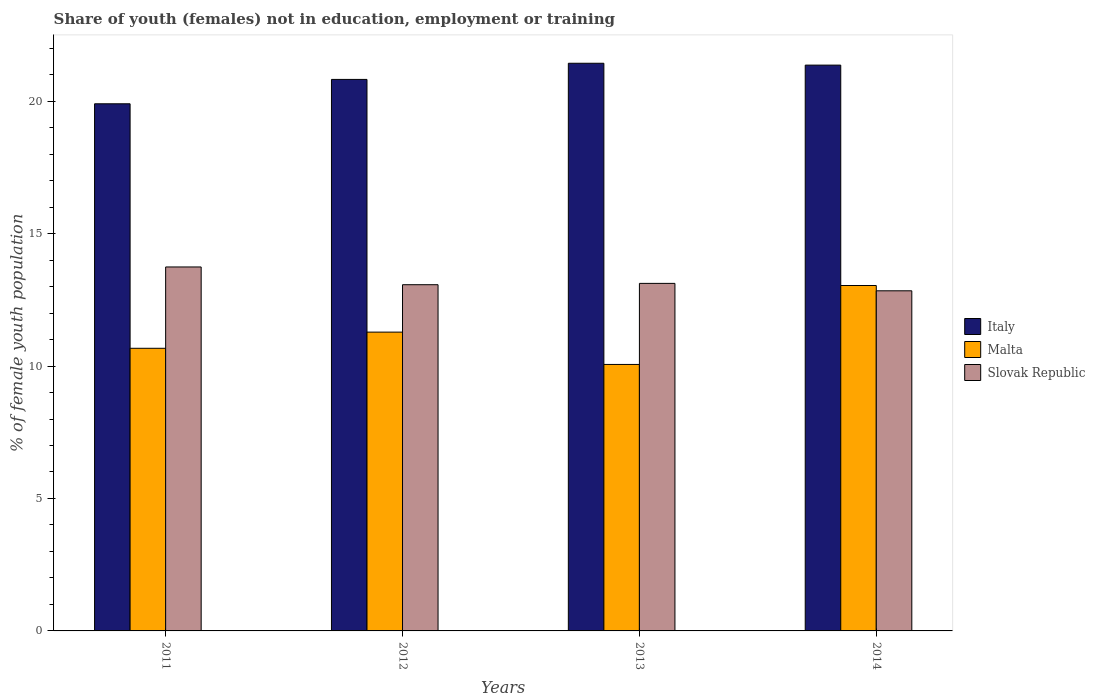How many bars are there on the 2nd tick from the left?
Your answer should be compact. 3. How many bars are there on the 3rd tick from the right?
Give a very brief answer. 3. What is the percentage of unemployed female population in in Malta in 2011?
Offer a very short reply. 10.67. Across all years, what is the maximum percentage of unemployed female population in in Malta?
Give a very brief answer. 13.04. Across all years, what is the minimum percentage of unemployed female population in in Italy?
Your response must be concise. 19.9. What is the total percentage of unemployed female population in in Italy in the graph?
Provide a short and direct response. 83.51. What is the difference between the percentage of unemployed female population in in Italy in 2012 and that in 2013?
Make the answer very short. -0.61. What is the difference between the percentage of unemployed female population in in Malta in 2011 and the percentage of unemployed female population in in Italy in 2012?
Offer a terse response. -10.15. What is the average percentage of unemployed female population in in Italy per year?
Your response must be concise. 20.88. In the year 2012, what is the difference between the percentage of unemployed female population in in Malta and percentage of unemployed female population in in Slovak Republic?
Your answer should be very brief. -1.79. In how many years, is the percentage of unemployed female population in in Slovak Republic greater than 14 %?
Your response must be concise. 0. What is the ratio of the percentage of unemployed female population in in Italy in 2013 to that in 2014?
Offer a terse response. 1. Is the difference between the percentage of unemployed female population in in Malta in 2012 and 2014 greater than the difference between the percentage of unemployed female population in in Slovak Republic in 2012 and 2014?
Ensure brevity in your answer.  No. What is the difference between the highest and the second highest percentage of unemployed female population in in Slovak Republic?
Keep it short and to the point. 0.62. What is the difference between the highest and the lowest percentage of unemployed female population in in Slovak Republic?
Your answer should be very brief. 0.9. In how many years, is the percentage of unemployed female population in in Italy greater than the average percentage of unemployed female population in in Italy taken over all years?
Your response must be concise. 2. Is the sum of the percentage of unemployed female population in in Italy in 2013 and 2014 greater than the maximum percentage of unemployed female population in in Slovak Republic across all years?
Make the answer very short. Yes. What does the 2nd bar from the left in 2014 represents?
Your response must be concise. Malta. What does the 2nd bar from the right in 2014 represents?
Ensure brevity in your answer.  Malta. How many bars are there?
Your response must be concise. 12. Are the values on the major ticks of Y-axis written in scientific E-notation?
Ensure brevity in your answer.  No. Does the graph contain any zero values?
Provide a short and direct response. No. Does the graph contain grids?
Give a very brief answer. No. Where does the legend appear in the graph?
Offer a very short reply. Center right. How many legend labels are there?
Keep it short and to the point. 3. How are the legend labels stacked?
Give a very brief answer. Vertical. What is the title of the graph?
Offer a very short reply. Share of youth (females) not in education, employment or training. What is the label or title of the Y-axis?
Your answer should be very brief. % of female youth population. What is the % of female youth population in Italy in 2011?
Your response must be concise. 19.9. What is the % of female youth population of Malta in 2011?
Give a very brief answer. 10.67. What is the % of female youth population of Slovak Republic in 2011?
Ensure brevity in your answer.  13.74. What is the % of female youth population of Italy in 2012?
Your response must be concise. 20.82. What is the % of female youth population of Malta in 2012?
Provide a short and direct response. 11.28. What is the % of female youth population in Slovak Republic in 2012?
Give a very brief answer. 13.07. What is the % of female youth population in Italy in 2013?
Make the answer very short. 21.43. What is the % of female youth population in Malta in 2013?
Offer a terse response. 10.06. What is the % of female youth population of Slovak Republic in 2013?
Offer a very short reply. 13.12. What is the % of female youth population in Italy in 2014?
Your answer should be compact. 21.36. What is the % of female youth population in Malta in 2014?
Ensure brevity in your answer.  13.04. What is the % of female youth population of Slovak Republic in 2014?
Make the answer very short. 12.84. Across all years, what is the maximum % of female youth population in Italy?
Make the answer very short. 21.43. Across all years, what is the maximum % of female youth population of Malta?
Offer a very short reply. 13.04. Across all years, what is the maximum % of female youth population of Slovak Republic?
Give a very brief answer. 13.74. Across all years, what is the minimum % of female youth population in Italy?
Give a very brief answer. 19.9. Across all years, what is the minimum % of female youth population in Malta?
Your answer should be very brief. 10.06. Across all years, what is the minimum % of female youth population of Slovak Republic?
Offer a very short reply. 12.84. What is the total % of female youth population in Italy in the graph?
Your response must be concise. 83.51. What is the total % of female youth population in Malta in the graph?
Your response must be concise. 45.05. What is the total % of female youth population in Slovak Republic in the graph?
Offer a terse response. 52.77. What is the difference between the % of female youth population in Italy in 2011 and that in 2012?
Your response must be concise. -0.92. What is the difference between the % of female youth population of Malta in 2011 and that in 2012?
Ensure brevity in your answer.  -0.61. What is the difference between the % of female youth population in Slovak Republic in 2011 and that in 2012?
Provide a succinct answer. 0.67. What is the difference between the % of female youth population in Italy in 2011 and that in 2013?
Give a very brief answer. -1.53. What is the difference between the % of female youth population in Malta in 2011 and that in 2013?
Keep it short and to the point. 0.61. What is the difference between the % of female youth population of Slovak Republic in 2011 and that in 2013?
Your answer should be very brief. 0.62. What is the difference between the % of female youth population of Italy in 2011 and that in 2014?
Your answer should be compact. -1.46. What is the difference between the % of female youth population in Malta in 2011 and that in 2014?
Provide a succinct answer. -2.37. What is the difference between the % of female youth population in Italy in 2012 and that in 2013?
Ensure brevity in your answer.  -0.61. What is the difference between the % of female youth population of Malta in 2012 and that in 2013?
Offer a very short reply. 1.22. What is the difference between the % of female youth population in Italy in 2012 and that in 2014?
Make the answer very short. -0.54. What is the difference between the % of female youth population in Malta in 2012 and that in 2014?
Offer a very short reply. -1.76. What is the difference between the % of female youth population of Slovak Republic in 2012 and that in 2014?
Provide a succinct answer. 0.23. What is the difference between the % of female youth population of Italy in 2013 and that in 2014?
Provide a succinct answer. 0.07. What is the difference between the % of female youth population in Malta in 2013 and that in 2014?
Your answer should be very brief. -2.98. What is the difference between the % of female youth population in Slovak Republic in 2013 and that in 2014?
Give a very brief answer. 0.28. What is the difference between the % of female youth population in Italy in 2011 and the % of female youth population in Malta in 2012?
Offer a terse response. 8.62. What is the difference between the % of female youth population in Italy in 2011 and the % of female youth population in Slovak Republic in 2012?
Keep it short and to the point. 6.83. What is the difference between the % of female youth population in Italy in 2011 and the % of female youth population in Malta in 2013?
Offer a terse response. 9.84. What is the difference between the % of female youth population in Italy in 2011 and the % of female youth population in Slovak Republic in 2013?
Your answer should be very brief. 6.78. What is the difference between the % of female youth population of Malta in 2011 and the % of female youth population of Slovak Republic in 2013?
Offer a terse response. -2.45. What is the difference between the % of female youth population of Italy in 2011 and the % of female youth population of Malta in 2014?
Offer a terse response. 6.86. What is the difference between the % of female youth population of Italy in 2011 and the % of female youth population of Slovak Republic in 2014?
Ensure brevity in your answer.  7.06. What is the difference between the % of female youth population in Malta in 2011 and the % of female youth population in Slovak Republic in 2014?
Give a very brief answer. -2.17. What is the difference between the % of female youth population in Italy in 2012 and the % of female youth population in Malta in 2013?
Your answer should be very brief. 10.76. What is the difference between the % of female youth population in Italy in 2012 and the % of female youth population in Slovak Republic in 2013?
Provide a succinct answer. 7.7. What is the difference between the % of female youth population in Malta in 2012 and the % of female youth population in Slovak Republic in 2013?
Give a very brief answer. -1.84. What is the difference between the % of female youth population in Italy in 2012 and the % of female youth population in Malta in 2014?
Your answer should be very brief. 7.78. What is the difference between the % of female youth population in Italy in 2012 and the % of female youth population in Slovak Republic in 2014?
Your response must be concise. 7.98. What is the difference between the % of female youth population in Malta in 2012 and the % of female youth population in Slovak Republic in 2014?
Ensure brevity in your answer.  -1.56. What is the difference between the % of female youth population in Italy in 2013 and the % of female youth population in Malta in 2014?
Your answer should be very brief. 8.39. What is the difference between the % of female youth population in Italy in 2013 and the % of female youth population in Slovak Republic in 2014?
Provide a succinct answer. 8.59. What is the difference between the % of female youth population of Malta in 2013 and the % of female youth population of Slovak Republic in 2014?
Your answer should be very brief. -2.78. What is the average % of female youth population in Italy per year?
Offer a very short reply. 20.88. What is the average % of female youth population in Malta per year?
Offer a terse response. 11.26. What is the average % of female youth population of Slovak Republic per year?
Your answer should be compact. 13.19. In the year 2011, what is the difference between the % of female youth population in Italy and % of female youth population in Malta?
Your answer should be very brief. 9.23. In the year 2011, what is the difference between the % of female youth population in Italy and % of female youth population in Slovak Republic?
Your response must be concise. 6.16. In the year 2011, what is the difference between the % of female youth population of Malta and % of female youth population of Slovak Republic?
Offer a terse response. -3.07. In the year 2012, what is the difference between the % of female youth population in Italy and % of female youth population in Malta?
Your answer should be very brief. 9.54. In the year 2012, what is the difference between the % of female youth population in Italy and % of female youth population in Slovak Republic?
Provide a short and direct response. 7.75. In the year 2012, what is the difference between the % of female youth population in Malta and % of female youth population in Slovak Republic?
Give a very brief answer. -1.79. In the year 2013, what is the difference between the % of female youth population of Italy and % of female youth population of Malta?
Offer a terse response. 11.37. In the year 2013, what is the difference between the % of female youth population of Italy and % of female youth population of Slovak Republic?
Your answer should be very brief. 8.31. In the year 2013, what is the difference between the % of female youth population in Malta and % of female youth population in Slovak Republic?
Offer a terse response. -3.06. In the year 2014, what is the difference between the % of female youth population of Italy and % of female youth population of Malta?
Provide a short and direct response. 8.32. In the year 2014, what is the difference between the % of female youth population of Italy and % of female youth population of Slovak Republic?
Your answer should be compact. 8.52. In the year 2014, what is the difference between the % of female youth population in Malta and % of female youth population in Slovak Republic?
Offer a terse response. 0.2. What is the ratio of the % of female youth population in Italy in 2011 to that in 2012?
Keep it short and to the point. 0.96. What is the ratio of the % of female youth population of Malta in 2011 to that in 2012?
Your answer should be compact. 0.95. What is the ratio of the % of female youth population of Slovak Republic in 2011 to that in 2012?
Give a very brief answer. 1.05. What is the ratio of the % of female youth population of Italy in 2011 to that in 2013?
Provide a short and direct response. 0.93. What is the ratio of the % of female youth population in Malta in 2011 to that in 2013?
Your response must be concise. 1.06. What is the ratio of the % of female youth population in Slovak Republic in 2011 to that in 2013?
Give a very brief answer. 1.05. What is the ratio of the % of female youth population in Italy in 2011 to that in 2014?
Your answer should be very brief. 0.93. What is the ratio of the % of female youth population of Malta in 2011 to that in 2014?
Your answer should be compact. 0.82. What is the ratio of the % of female youth population of Slovak Republic in 2011 to that in 2014?
Your response must be concise. 1.07. What is the ratio of the % of female youth population of Italy in 2012 to that in 2013?
Ensure brevity in your answer.  0.97. What is the ratio of the % of female youth population of Malta in 2012 to that in 2013?
Your answer should be very brief. 1.12. What is the ratio of the % of female youth population of Italy in 2012 to that in 2014?
Offer a terse response. 0.97. What is the ratio of the % of female youth population of Malta in 2012 to that in 2014?
Make the answer very short. 0.86. What is the ratio of the % of female youth population of Slovak Republic in 2012 to that in 2014?
Ensure brevity in your answer.  1.02. What is the ratio of the % of female youth population of Malta in 2013 to that in 2014?
Provide a succinct answer. 0.77. What is the ratio of the % of female youth population of Slovak Republic in 2013 to that in 2014?
Offer a terse response. 1.02. What is the difference between the highest and the second highest % of female youth population in Italy?
Offer a very short reply. 0.07. What is the difference between the highest and the second highest % of female youth population of Malta?
Offer a terse response. 1.76. What is the difference between the highest and the second highest % of female youth population in Slovak Republic?
Offer a terse response. 0.62. What is the difference between the highest and the lowest % of female youth population in Italy?
Make the answer very short. 1.53. What is the difference between the highest and the lowest % of female youth population of Malta?
Your answer should be very brief. 2.98. What is the difference between the highest and the lowest % of female youth population of Slovak Republic?
Offer a terse response. 0.9. 